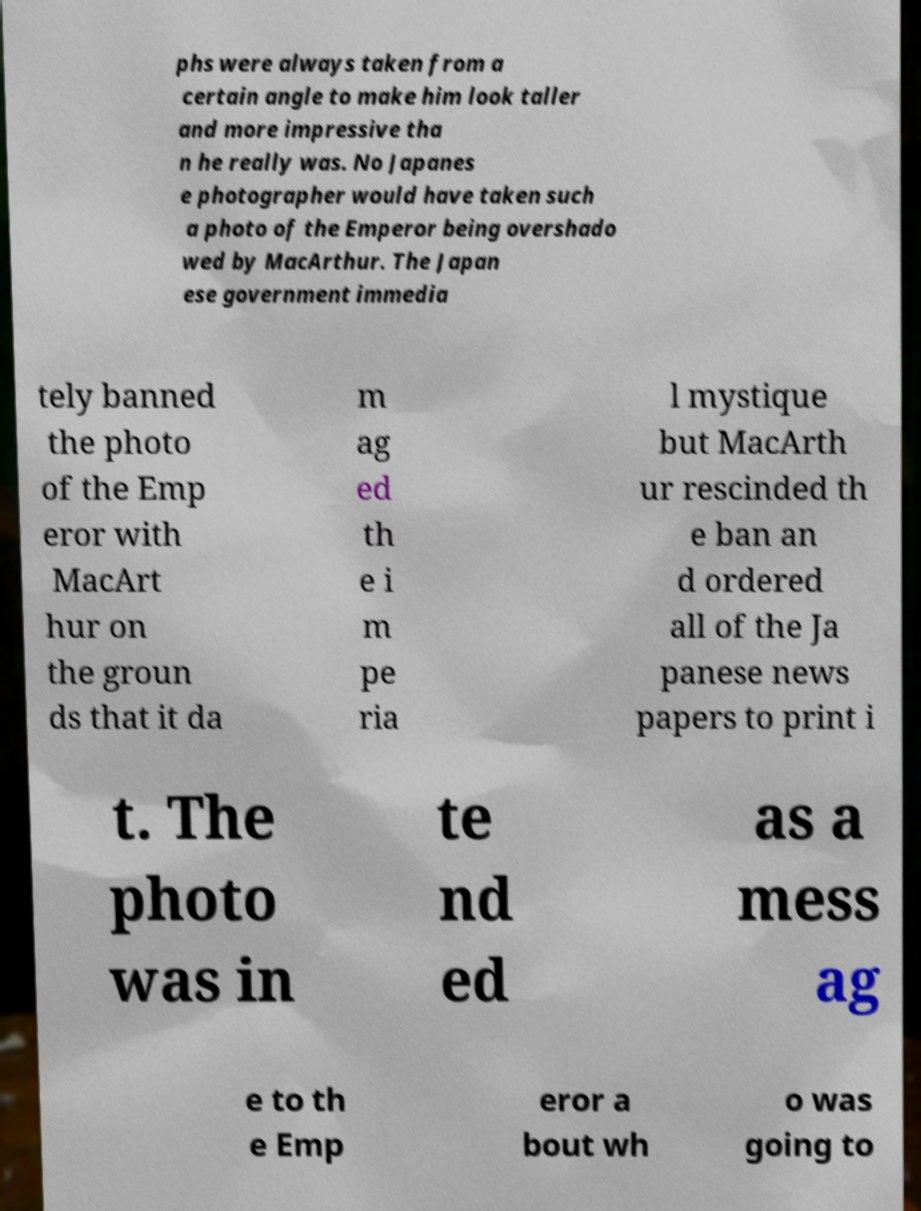What messages or text are displayed in this image? I need them in a readable, typed format. phs were always taken from a certain angle to make him look taller and more impressive tha n he really was. No Japanes e photographer would have taken such a photo of the Emperor being overshado wed by MacArthur. The Japan ese government immedia tely banned the photo of the Emp eror with MacArt hur on the groun ds that it da m ag ed th e i m pe ria l mystique but MacArth ur rescinded th e ban an d ordered all of the Ja panese news papers to print i t. The photo was in te nd ed as a mess ag e to th e Emp eror a bout wh o was going to 